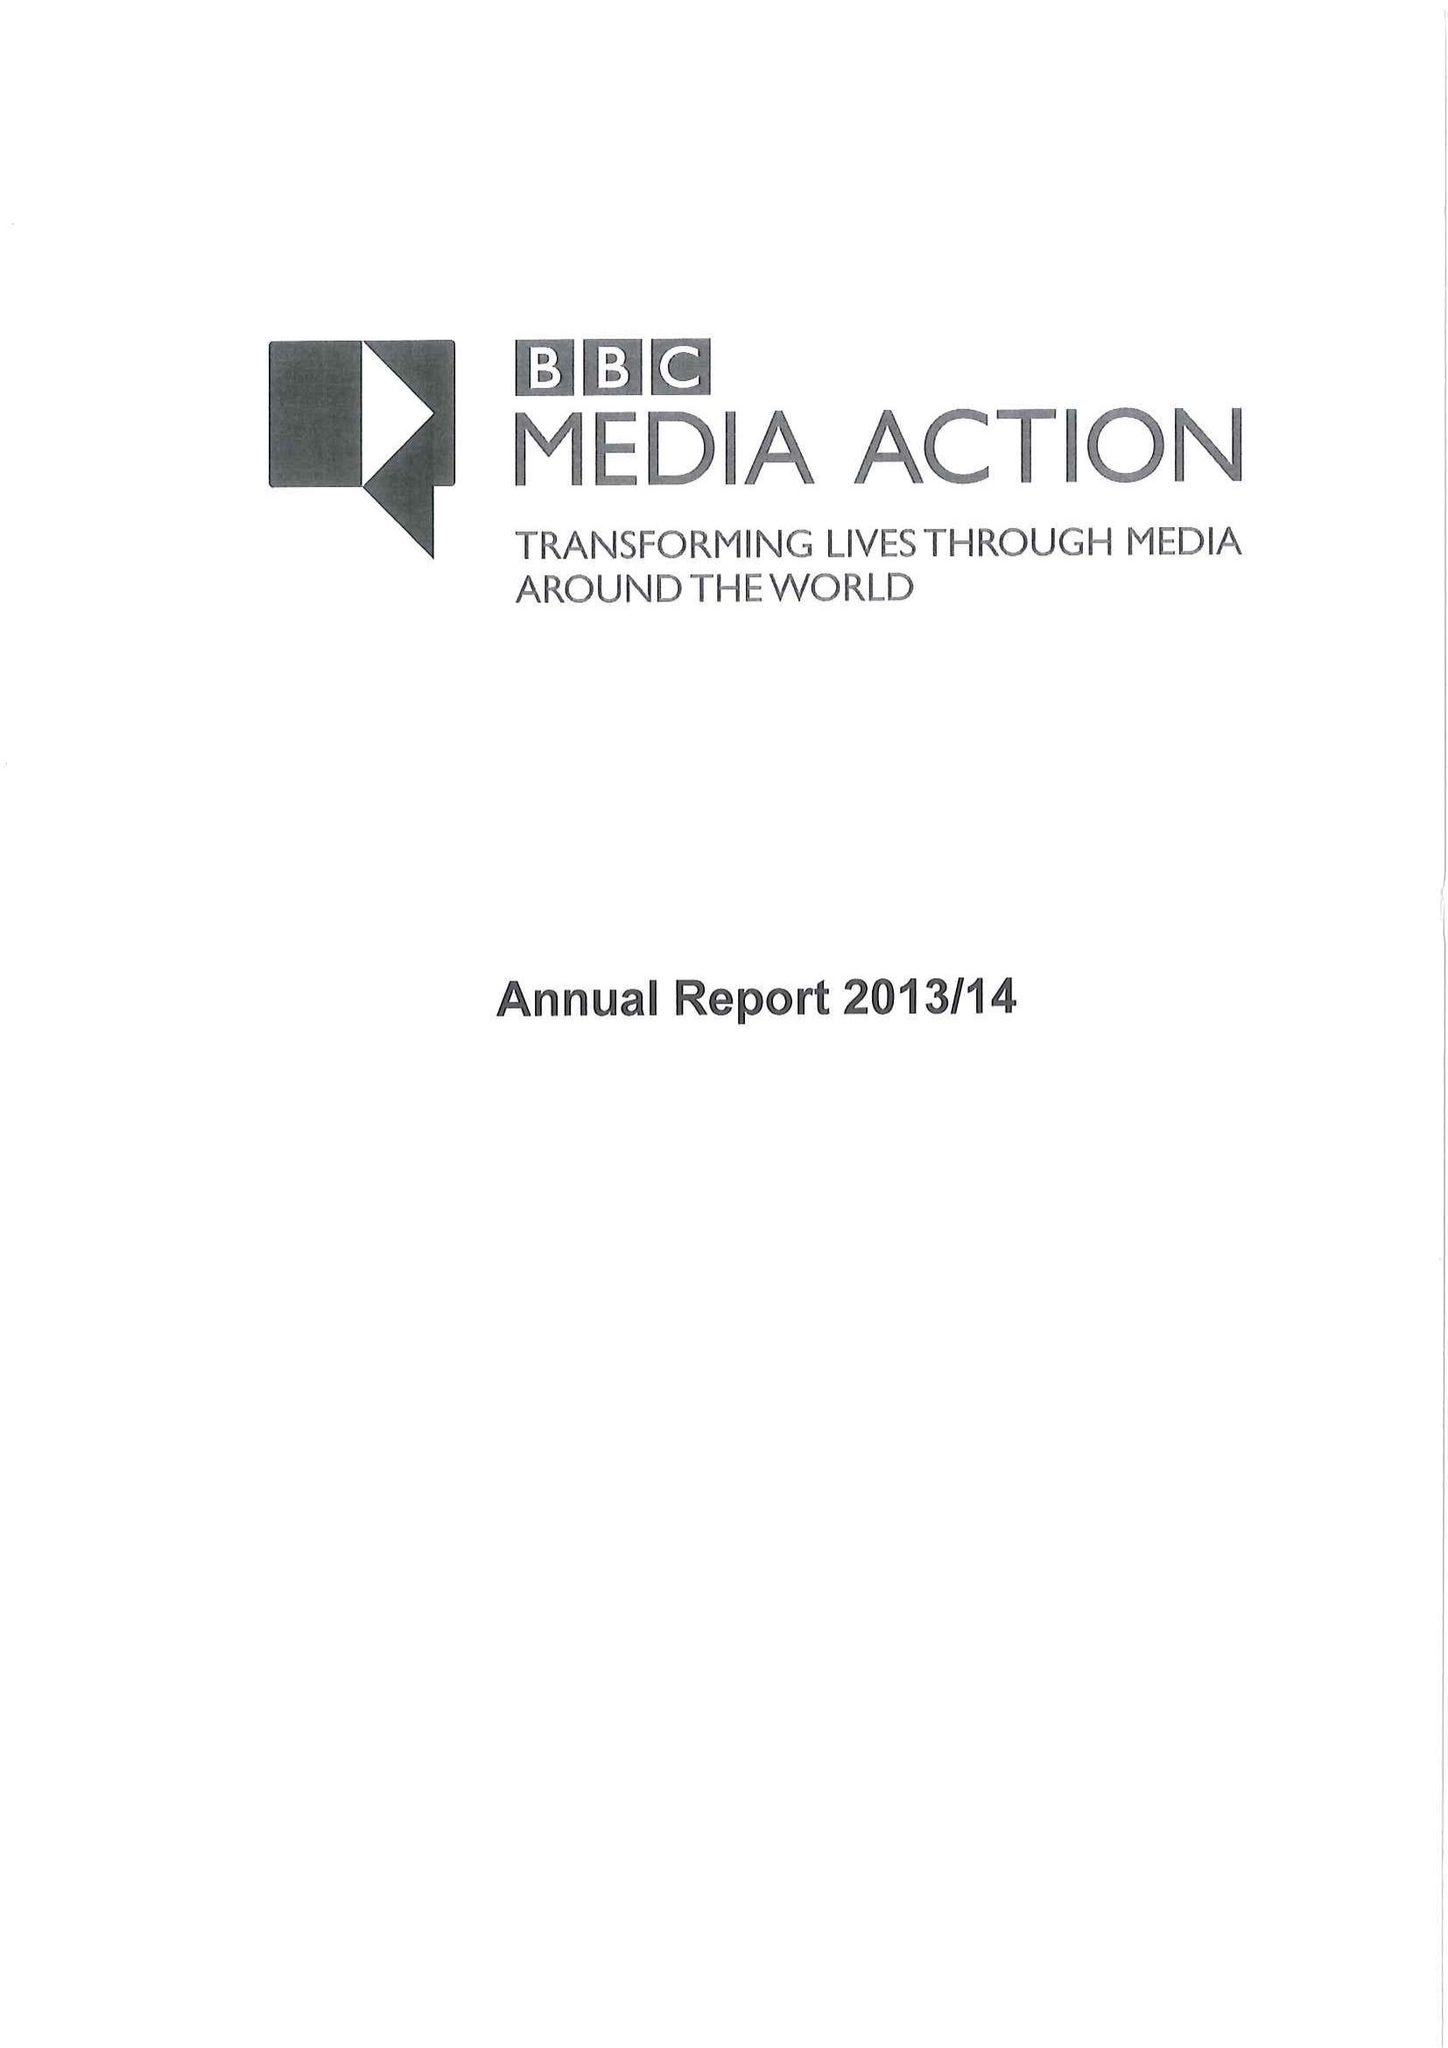What is the value for the address__post_town?
Answer the question using a single word or phrase. LONDON 